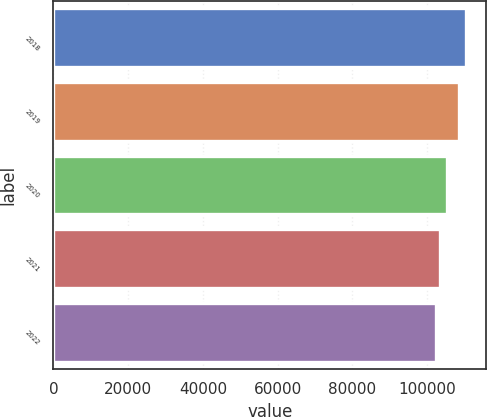Convert chart. <chart><loc_0><loc_0><loc_500><loc_500><bar_chart><fcel>2018<fcel>2019<fcel>2020<fcel>2021<fcel>2022<nl><fcel>110388<fcel>108604<fcel>105341<fcel>103358<fcel>102335<nl></chart> 